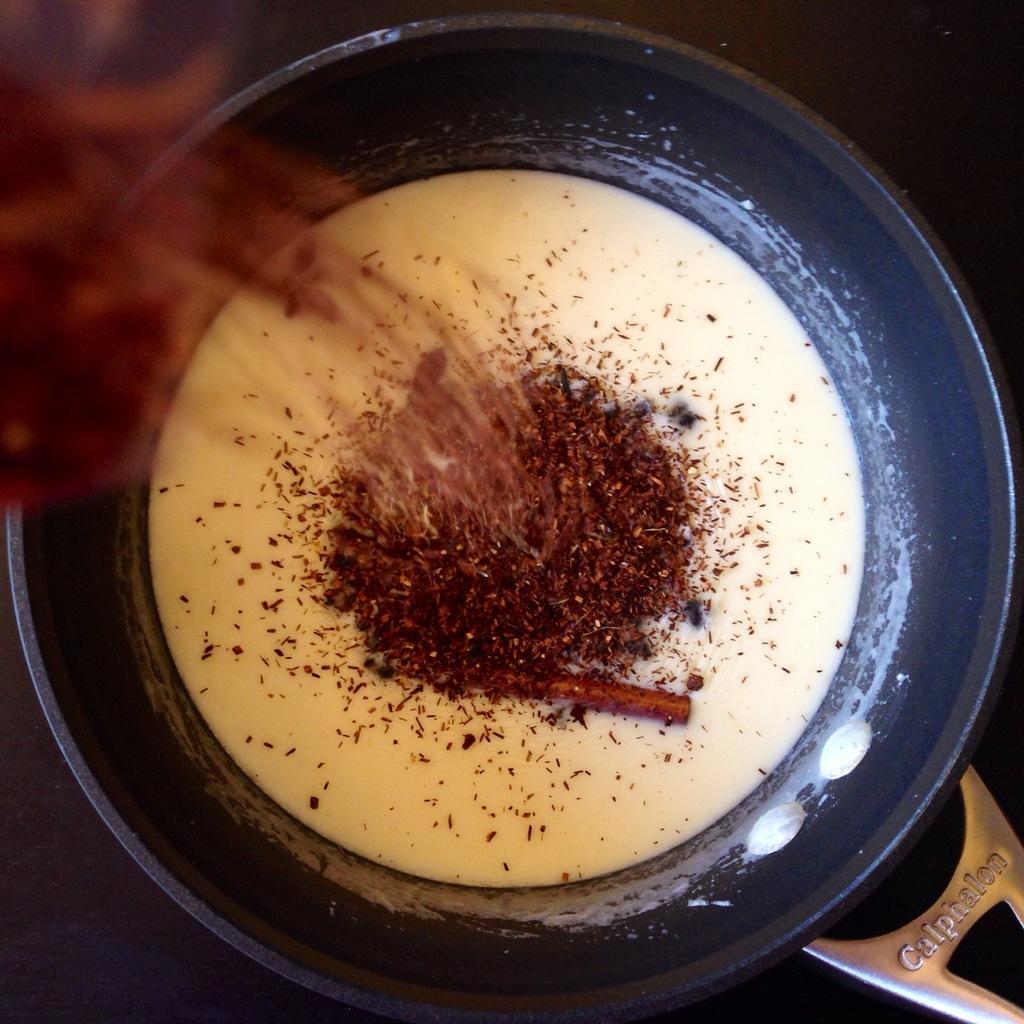Could you give a brief overview of what you see in this image? In this picture I can see a utensil in front, in which I can see white color liquid and brown color power. On the bottom right corner of this picture, I can see a silver thing and I see a word written on it. 